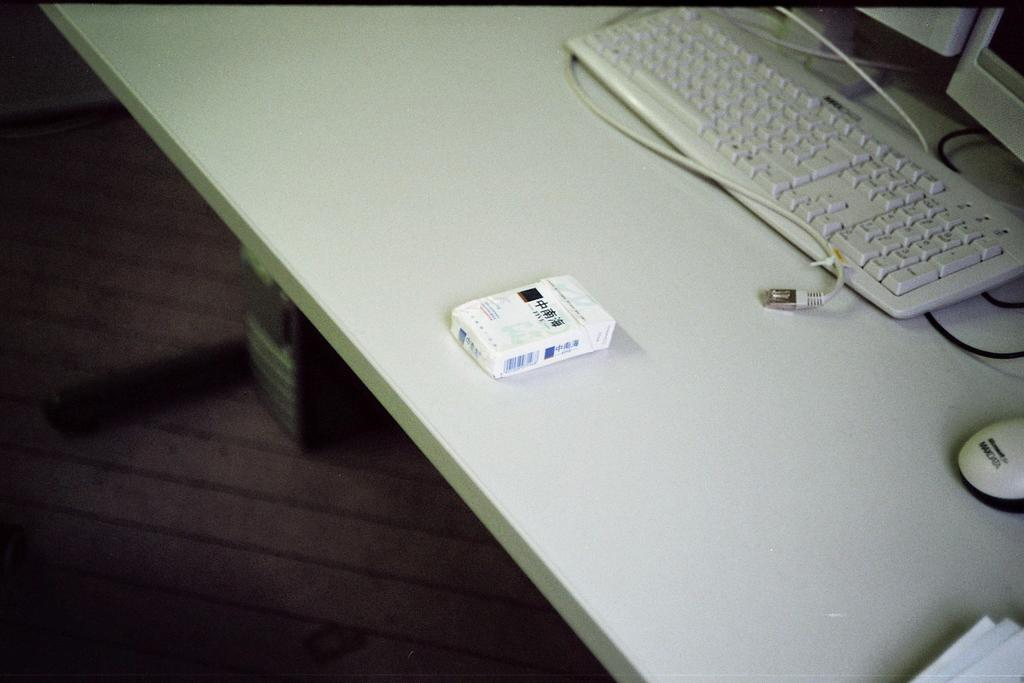<image>
Present a compact description of the photo's key features. The pack of cigarettes are near the Maxdata mouse. 